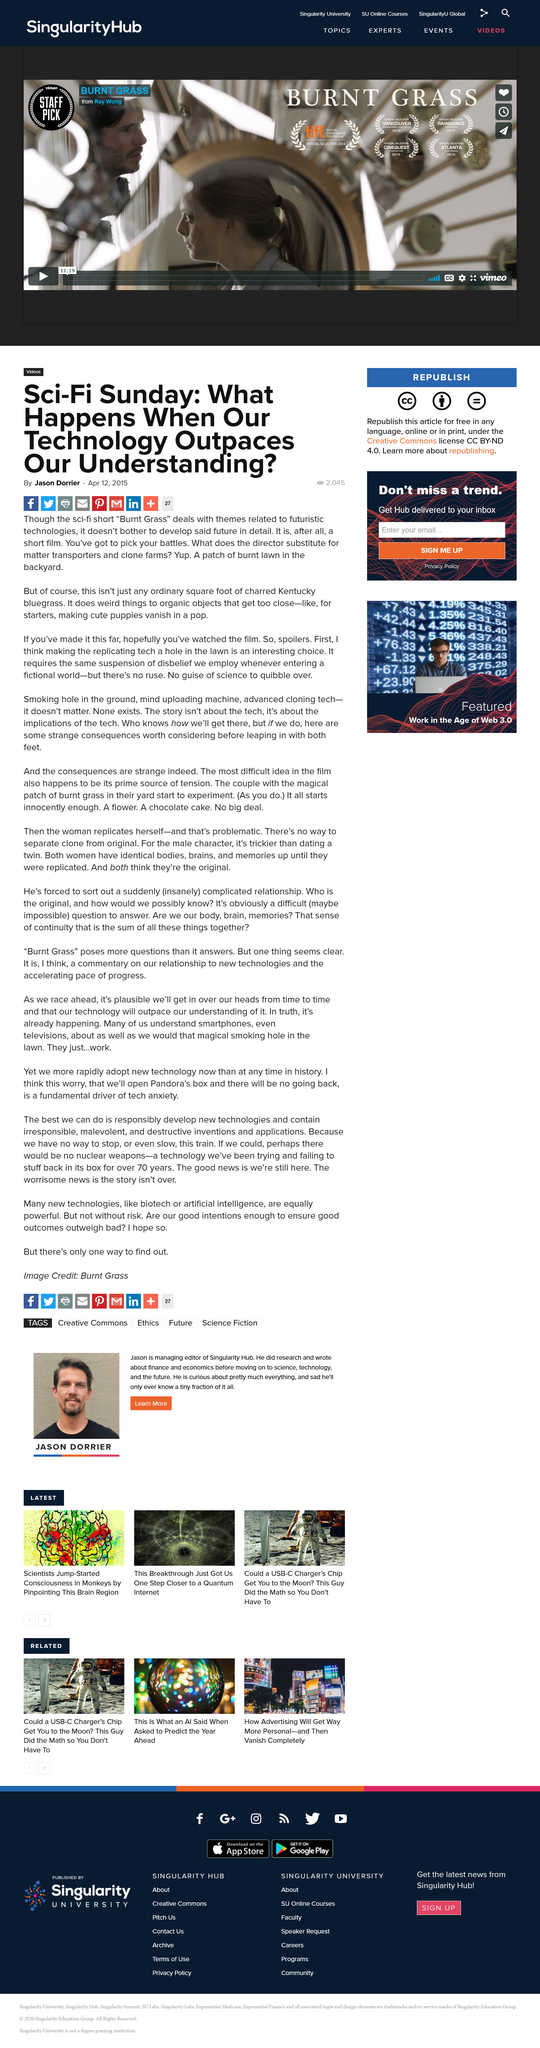Specify some key components in this picture. The author of the text is Jason Dorrier. It has received 2045 views. The article "Sci-Fi Sunday" is shareable on Facebook. 